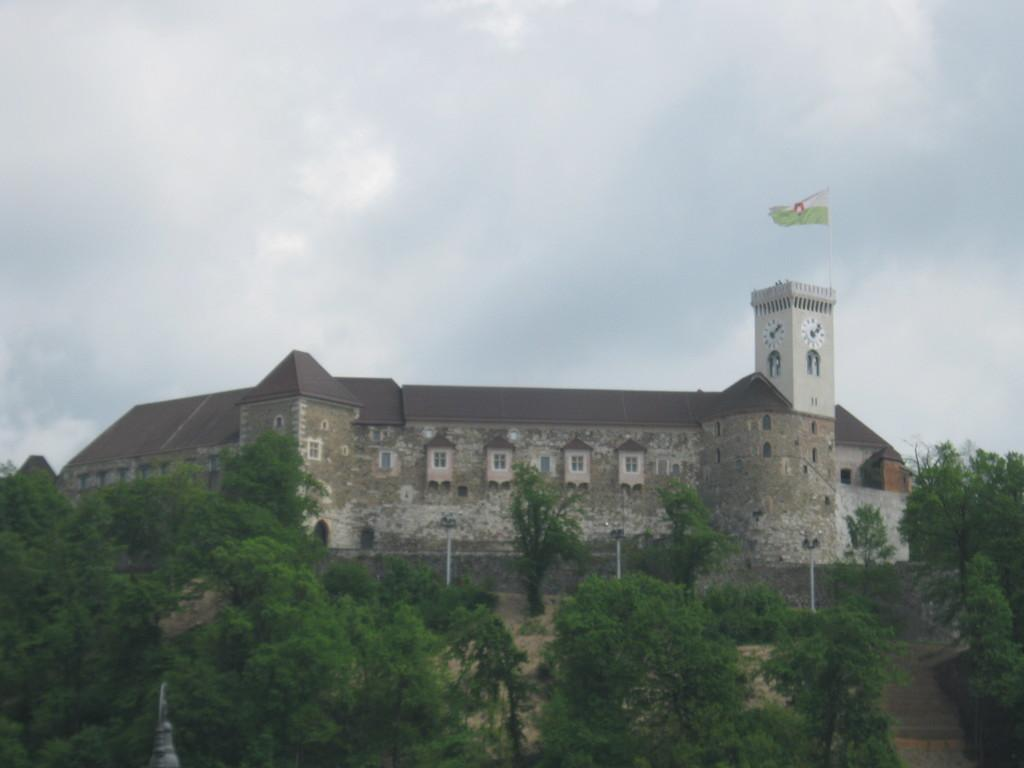What is located in the foreground of the image? There are trees in front of the image. What is the main structure in the image? There is a building in the center of the image. What additional feature can be seen in the image? There is a flag in the image. What can be seen in the background of the image? There is sky visible in the background of the image. What type of harmony is being played in the background of the image? There is no music or harmony present in the image; it features trees, a building, a flag, and sky. Can you tell me how many volleyballs are visible in the image? There are no volleyballs present in the image. 